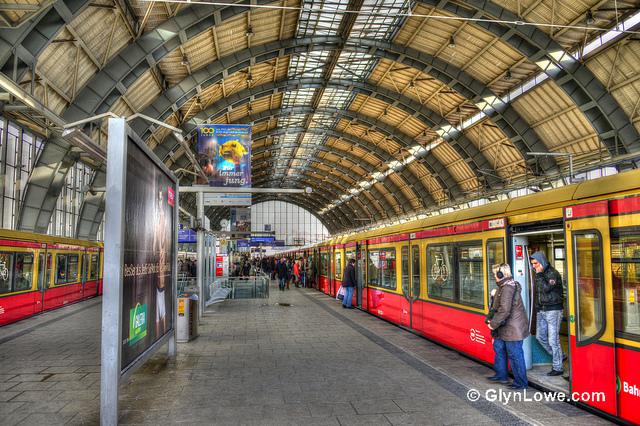Are the people closest to us boarding or leaving the train?
Keep it brief. Leaving. Are the people wearing jackets?
Short answer required. Yes. Is the train stopped or moving?
Short answer required. Stopped. 